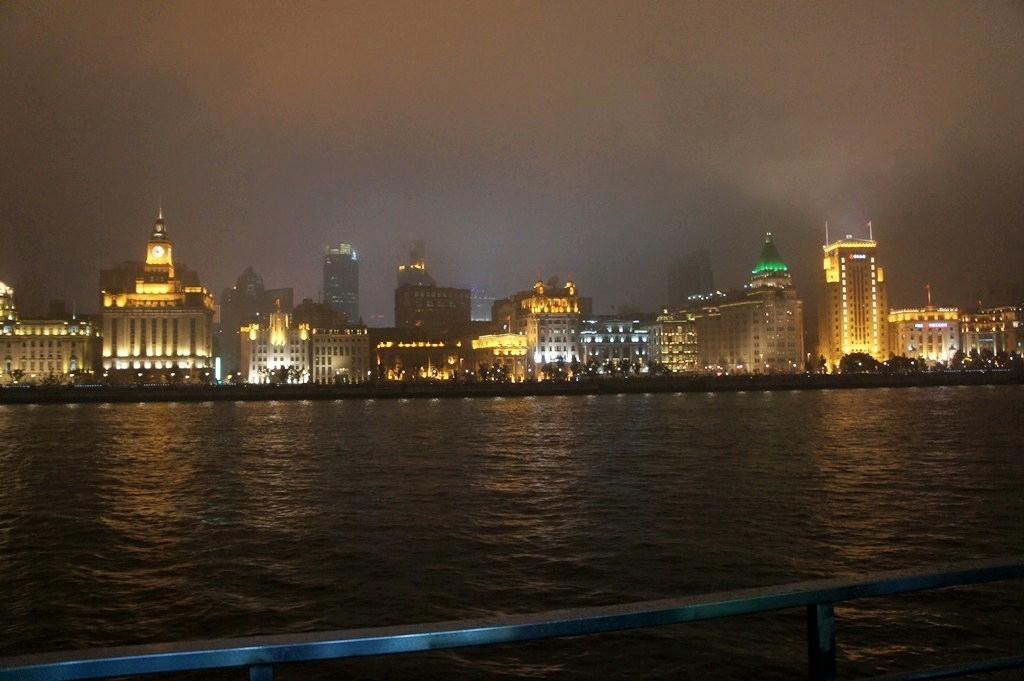What objects can be seen in the image? There are iron rods in the image. What else can be seen besides the iron rods? There is water visible in the image. What can be seen in the background of the image? There are trees, buildings with lights, and the sky visible in the background of the image. What type of activity is the crook participating in with the iron rods in the image? There is no crook present in the image, and therefore no such activity can be observed. 